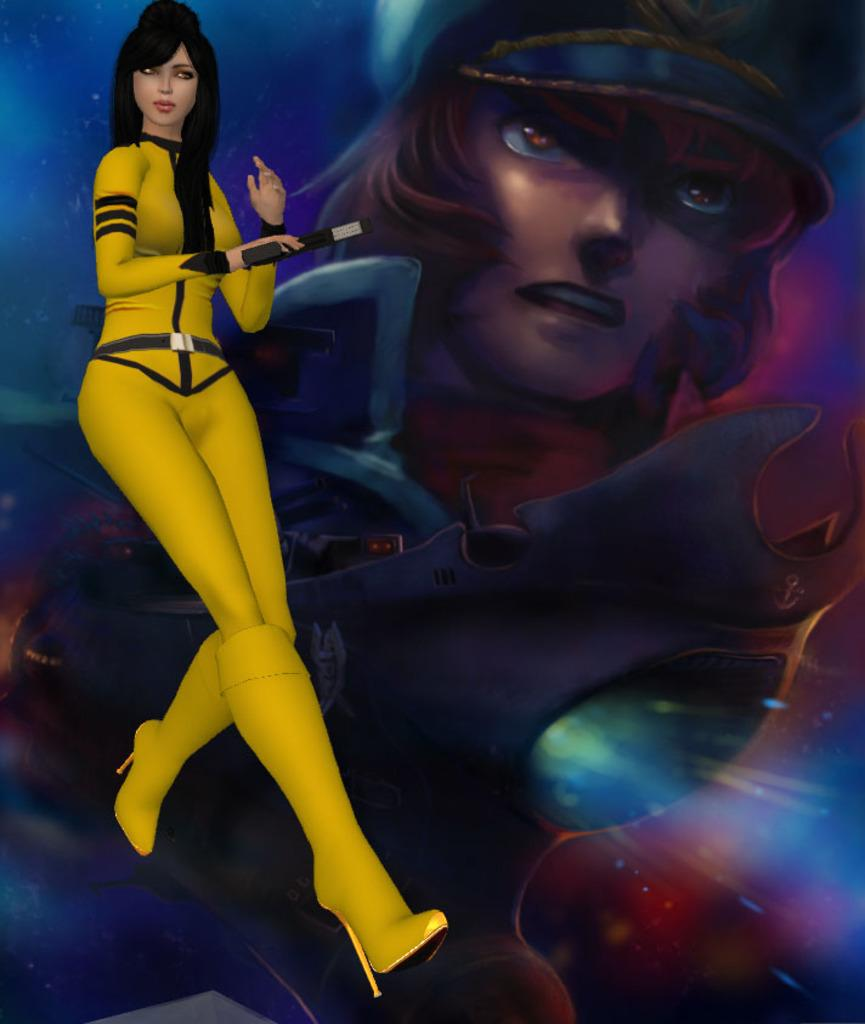Who is the main subject in the image? There is a woman in the image. What type of image is it? The image is animated. What can be seen in the background of the image? There is a poster in the background of the image. How many geese are resting on the woman's throat in the image? There are no geese present in the image, and the woman's throat is not visible. 